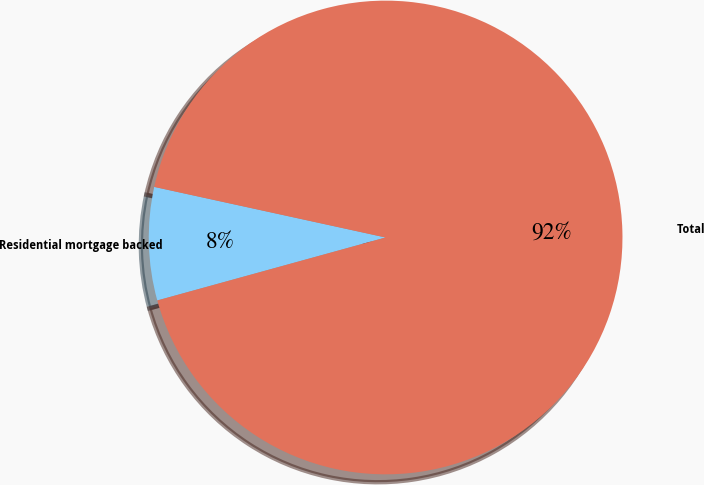Convert chart. <chart><loc_0><loc_0><loc_500><loc_500><pie_chart><fcel>Residential mortgage backed<fcel>Total<nl><fcel>7.71%<fcel>92.29%<nl></chart> 